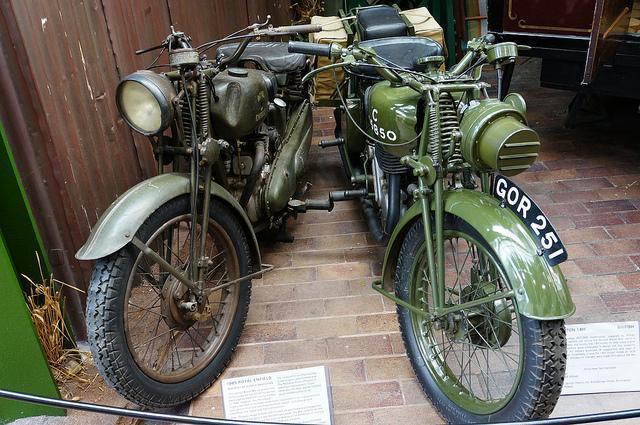How many motorcycles are visible?
Give a very brief answer. 2. 